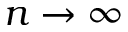Convert formula to latex. <formula><loc_0><loc_0><loc_500><loc_500>n \rightarrow \infty</formula> 